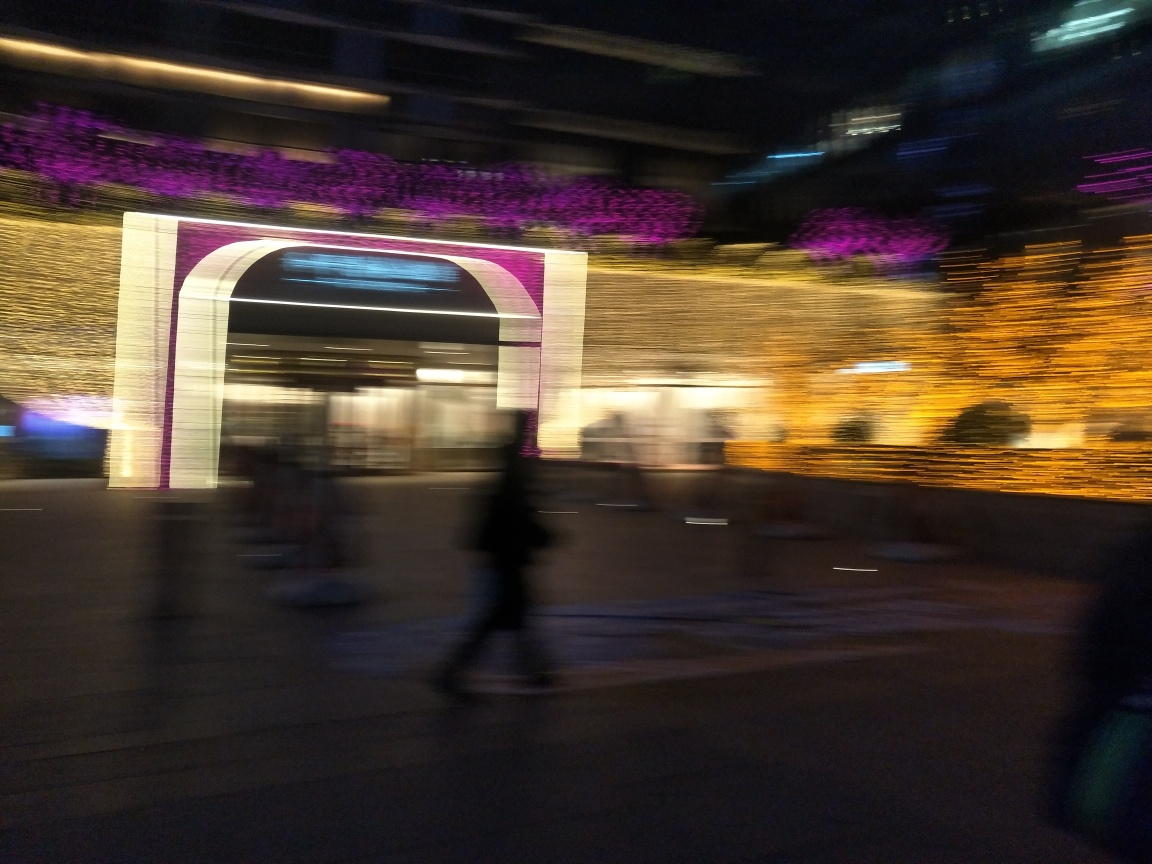Can you tell what time of day it is or describe the lighting conditions in this image? The image appears to have been taken in a low-light environment, possibly during evening or night time, as evidenced by the artificial lighting and the absence of natural light. 